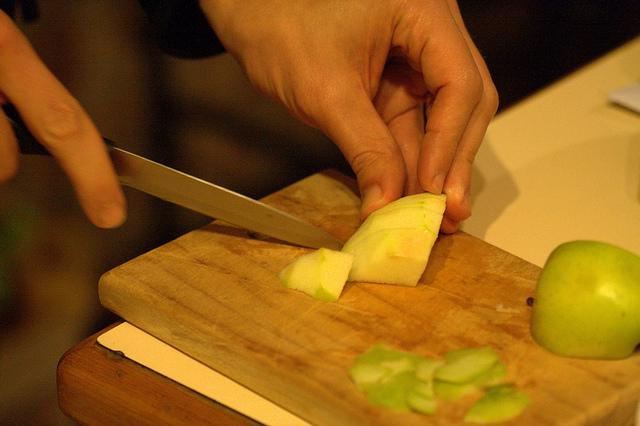What is this type of apple called?

Choices:
A) ladybug
B) granny smith
C) red delicious
D) baking granny smith 